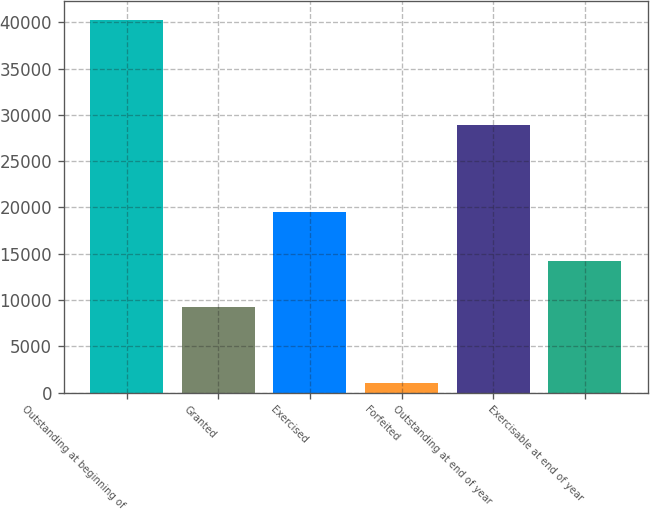<chart> <loc_0><loc_0><loc_500><loc_500><bar_chart><fcel>Outstanding at beginning of<fcel>Granted<fcel>Exercised<fcel>Forfeited<fcel>Outstanding at end of year<fcel>Exercisable at end of year<nl><fcel>40311<fcel>9246<fcel>19533<fcel>1081<fcel>28943<fcel>14252<nl></chart> 